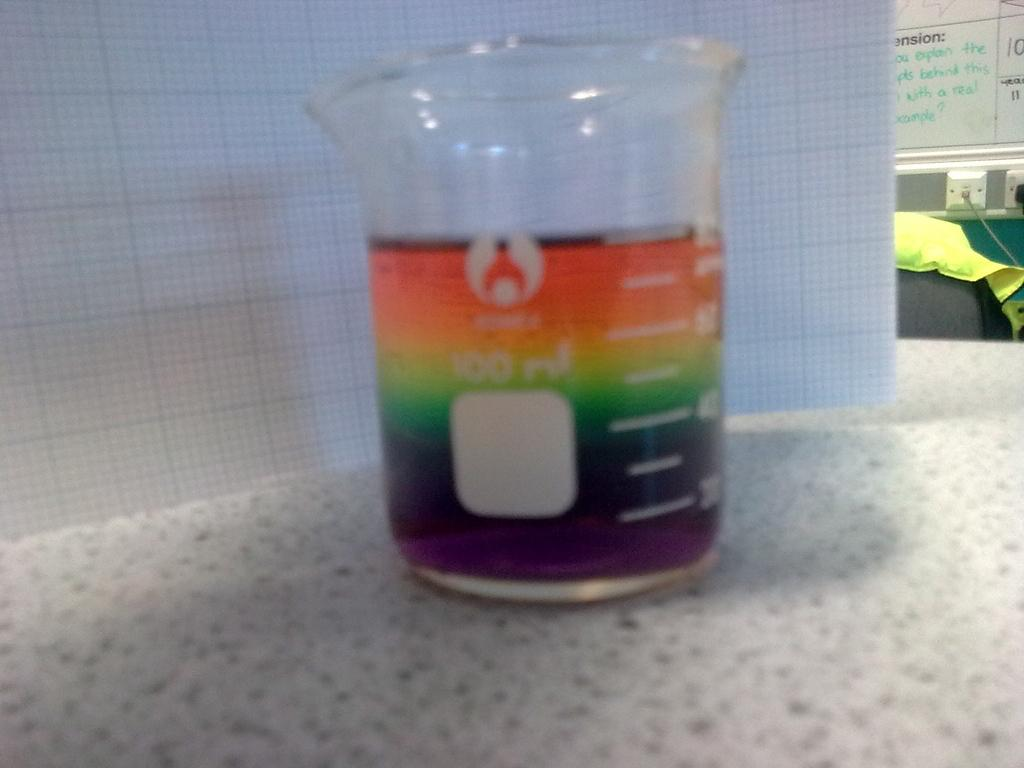<image>
Create a compact narrative representing the image presented. The measuring cup is marked where 100 ml is the maximum measurement. 